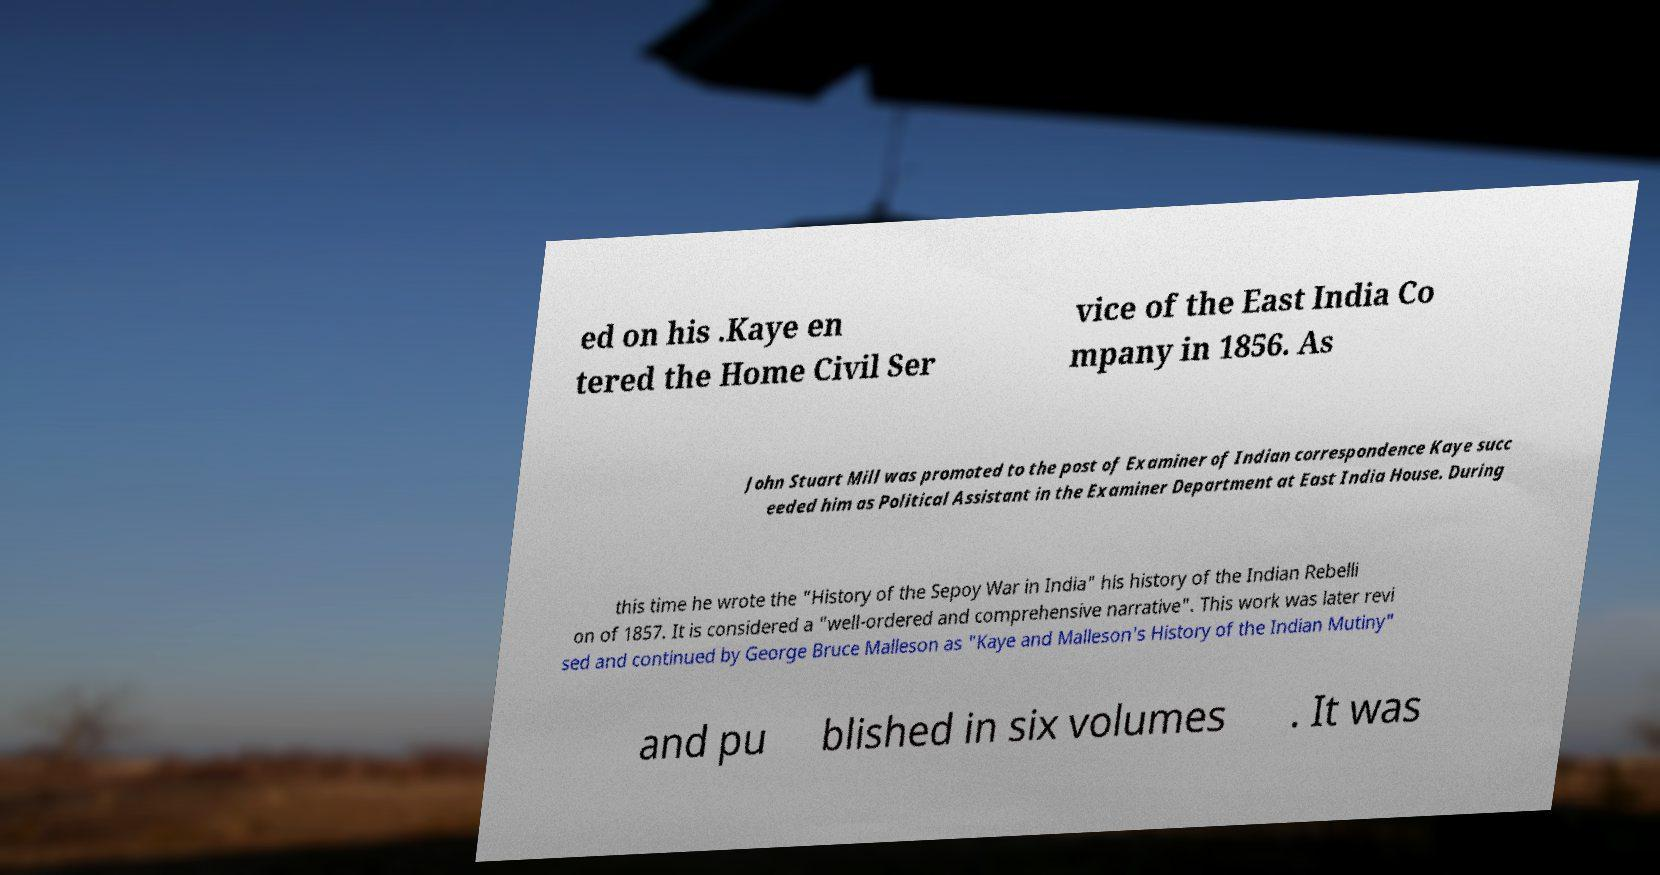Please identify and transcribe the text found in this image. ed on his .Kaye en tered the Home Civil Ser vice of the East India Co mpany in 1856. As John Stuart Mill was promoted to the post of Examiner of Indian correspondence Kaye succ eeded him as Political Assistant in the Examiner Department at East India House. During this time he wrote the "History of the Sepoy War in India" his history of the Indian Rebelli on of 1857. It is considered a "well-ordered and comprehensive narrative". This work was later revi sed and continued by George Bruce Malleson as "Kaye and Malleson's History of the Indian Mutiny" and pu blished in six volumes . It was 